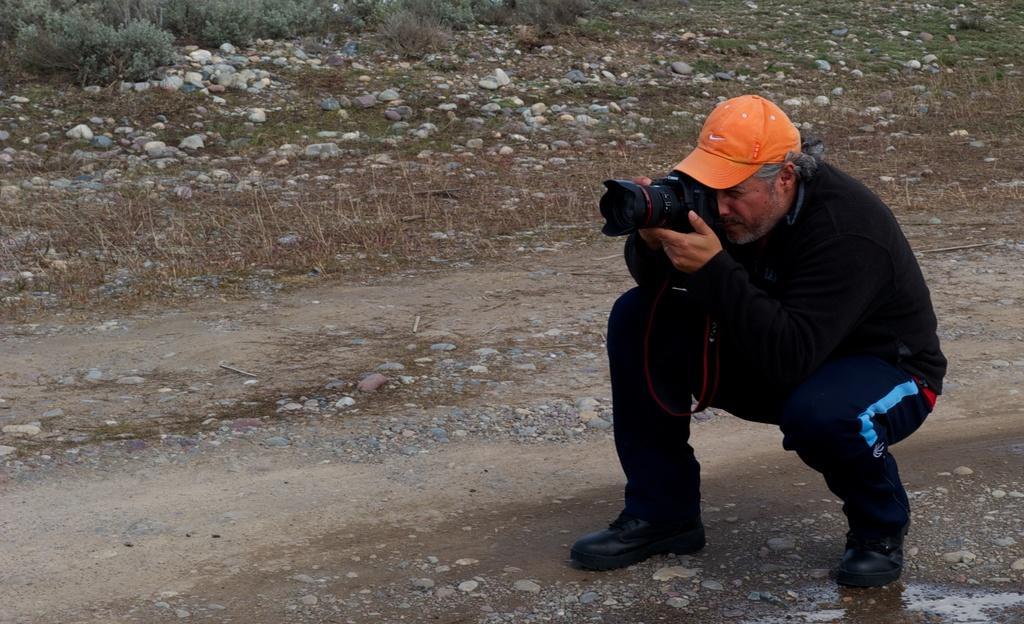Could you give a brief overview of what you see in this image? This is a picture of a man taking photographs with a camera wearing a black hoodie and a orange cap. In the background there are few plants and stones all over the background and path in the foreground 